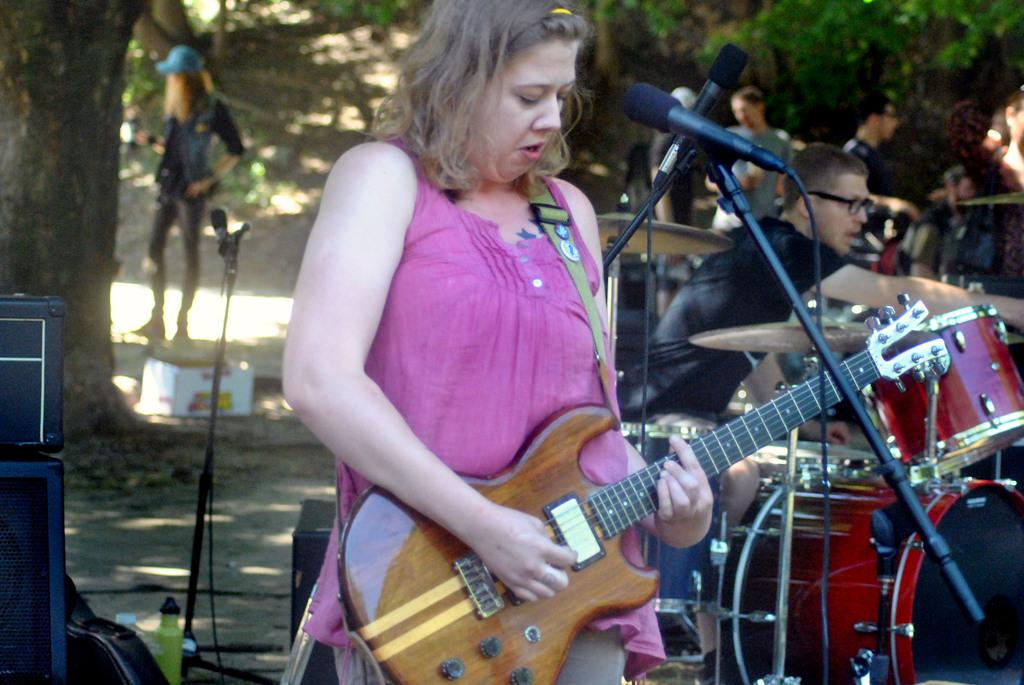What is the woman in the image doing? The woman is singing on a microphone and holding a guitar. What are the other men in the image doing? The men are playing musical instruments. Can you describe the presence of a tree in the image? Yes, there is a tree in the image. What type of lace is being used to decorate the microphone in the image? There is no lace present on the microphone in the image. What is the zinc content of the guitar strings in the image? There is no information about the guitar strings' composition in the image. 